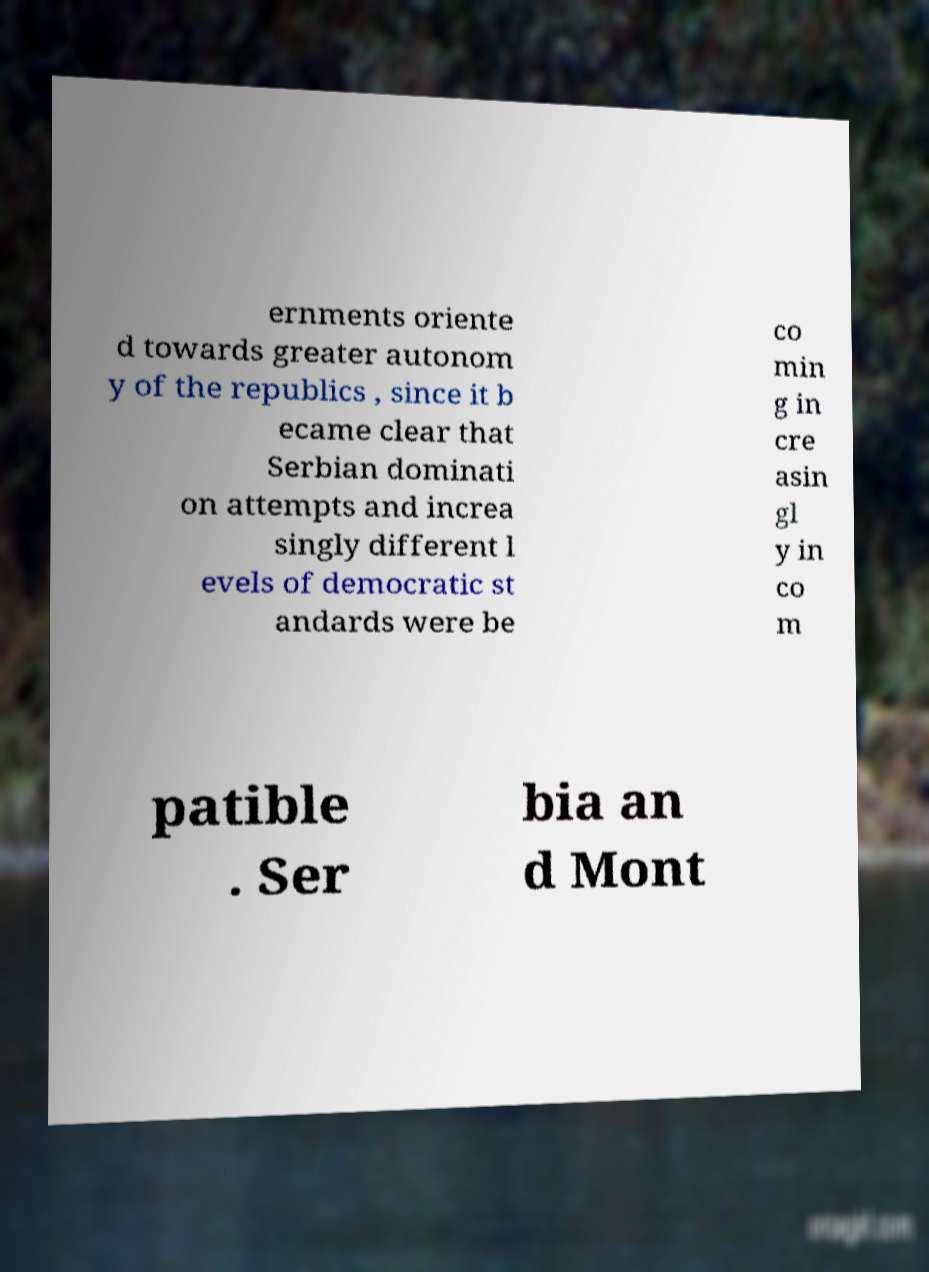Can you read and provide the text displayed in the image?This photo seems to have some interesting text. Can you extract and type it out for me? ernments oriente d towards greater autonom y of the republics , since it b ecame clear that Serbian dominati on attempts and increa singly different l evels of democratic st andards were be co min g in cre asin gl y in co m patible . Ser bia an d Mont 